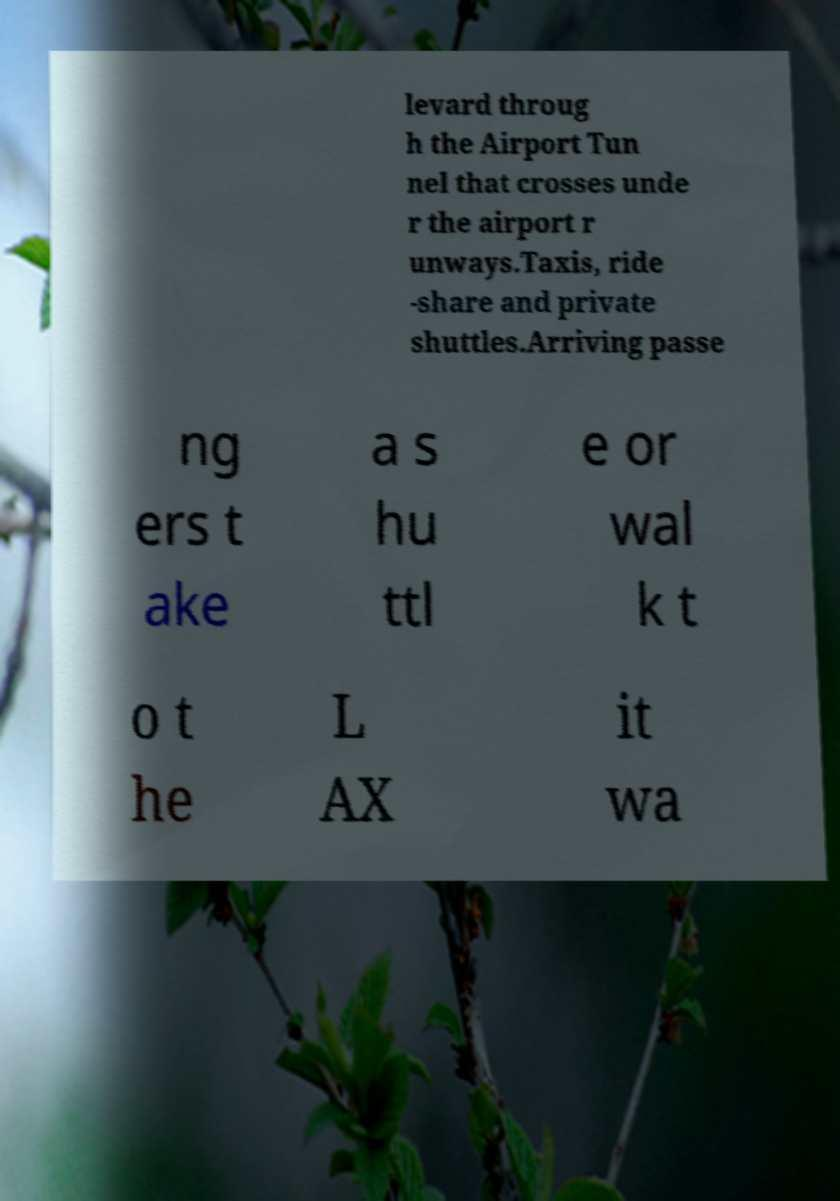What messages or text are displayed in this image? I need them in a readable, typed format. levard throug h the Airport Tun nel that crosses unde r the airport r unways.Taxis, ride -share and private shuttles.Arriving passe ng ers t ake a s hu ttl e or wal k t o t he L AX it wa 